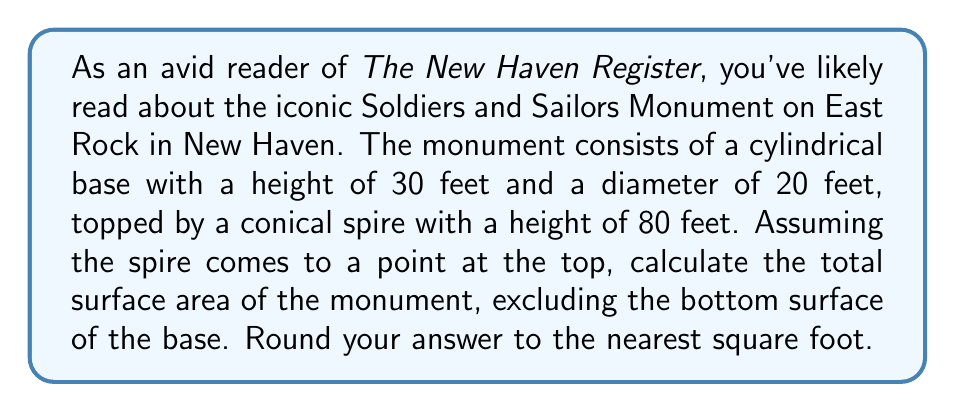Help me with this question. To solve this problem, we need to calculate the surface area of two parts: the cylindrical base and the conical spire.

1. Surface area of the cylindrical base:
   - Lateral surface area of cylinder: $A_{cylinder} = 2\pi rh$
   - $r = 10$ feet (radius = diameter/2)
   - $h = 30$ feet
   - $A_{cylinder} = 2\pi (10)(30) = 600\pi$ sq ft

2. Surface area of the conical spire:
   - Surface area of cone: $A_{cone} = \pi r\sqrt{r^2 + h^2}$
   - $r = 10$ feet (same as base radius)
   - $h = 80$ feet
   - $A_{cone} = \pi (10)\sqrt{10^2 + 80^2} = 10\pi\sqrt{6500}$ sq ft

3. Total surface area:
   $A_{total} = A_{cylinder} + A_{cone}$
   $A_{total} = 600\pi + 10\pi\sqrt{6500}$
   $A_{total} = 10\pi(60 + \sqrt{6500})$ sq ft

4. Simplifying:
   $A_{total} \approx 3215.39$ sq ft

5. Rounding to the nearest square foot:
   $A_{total} \approx 3215$ sq ft
Answer: The total surface area of the Soldiers and Sailors Monument is approximately 3,215 square feet. 